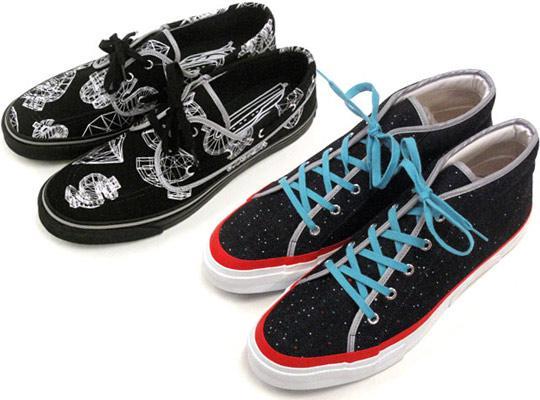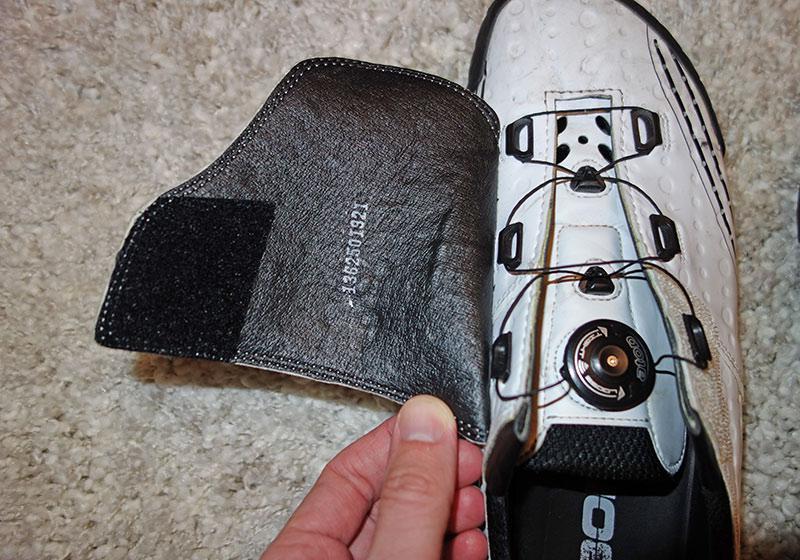The first image is the image on the left, the second image is the image on the right. Assess this claim about the two images: "There are exactly eight shoes visible.". Correct or not? Answer yes or no. No. The first image is the image on the left, the second image is the image on the right. Given the left and right images, does the statement "At least one person is wearing the shoes." hold true? Answer yes or no. No. 